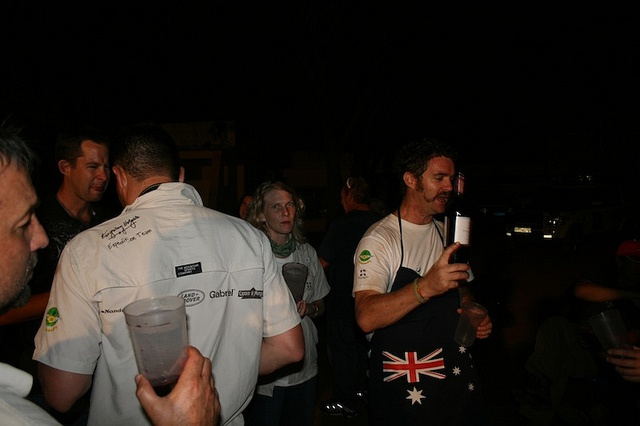Describe the objects in this image and their specific colors. I can see people in black, darkgray, and gray tones, people in black, maroon, and gray tones, people in black, maroon, and gray tones, people in black, maroon, and brown tones, and people in black, gray, and maroon tones in this image. 